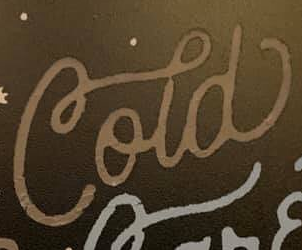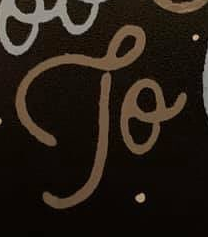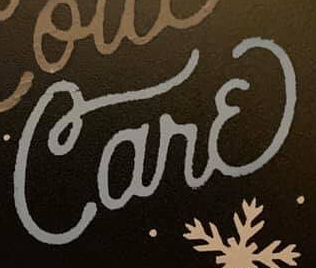What text appears in these images from left to right, separated by a semicolon? Cold; To; Carɛ 